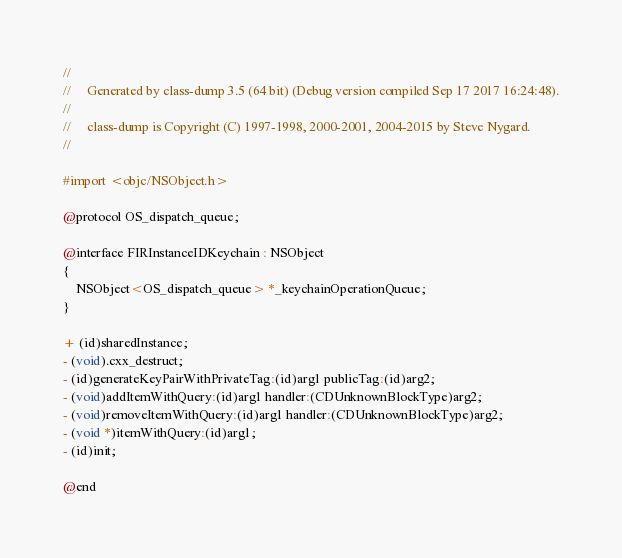Convert code to text. <code><loc_0><loc_0><loc_500><loc_500><_C_>//
//     Generated by class-dump 3.5 (64 bit) (Debug version compiled Sep 17 2017 16:24:48).
//
//     class-dump is Copyright (C) 1997-1998, 2000-2001, 2004-2015 by Steve Nygard.
//

#import <objc/NSObject.h>

@protocol OS_dispatch_queue;

@interface FIRInstanceIDKeychain : NSObject
{
    NSObject<OS_dispatch_queue> *_keychainOperationQueue;
}

+ (id)sharedInstance;
- (void).cxx_destruct;
- (id)generateKeyPairWithPrivateTag:(id)arg1 publicTag:(id)arg2;
- (void)addItemWithQuery:(id)arg1 handler:(CDUnknownBlockType)arg2;
- (void)removeItemWithQuery:(id)arg1 handler:(CDUnknownBlockType)arg2;
- (void *)itemWithQuery:(id)arg1;
- (id)init;

@end

</code> 